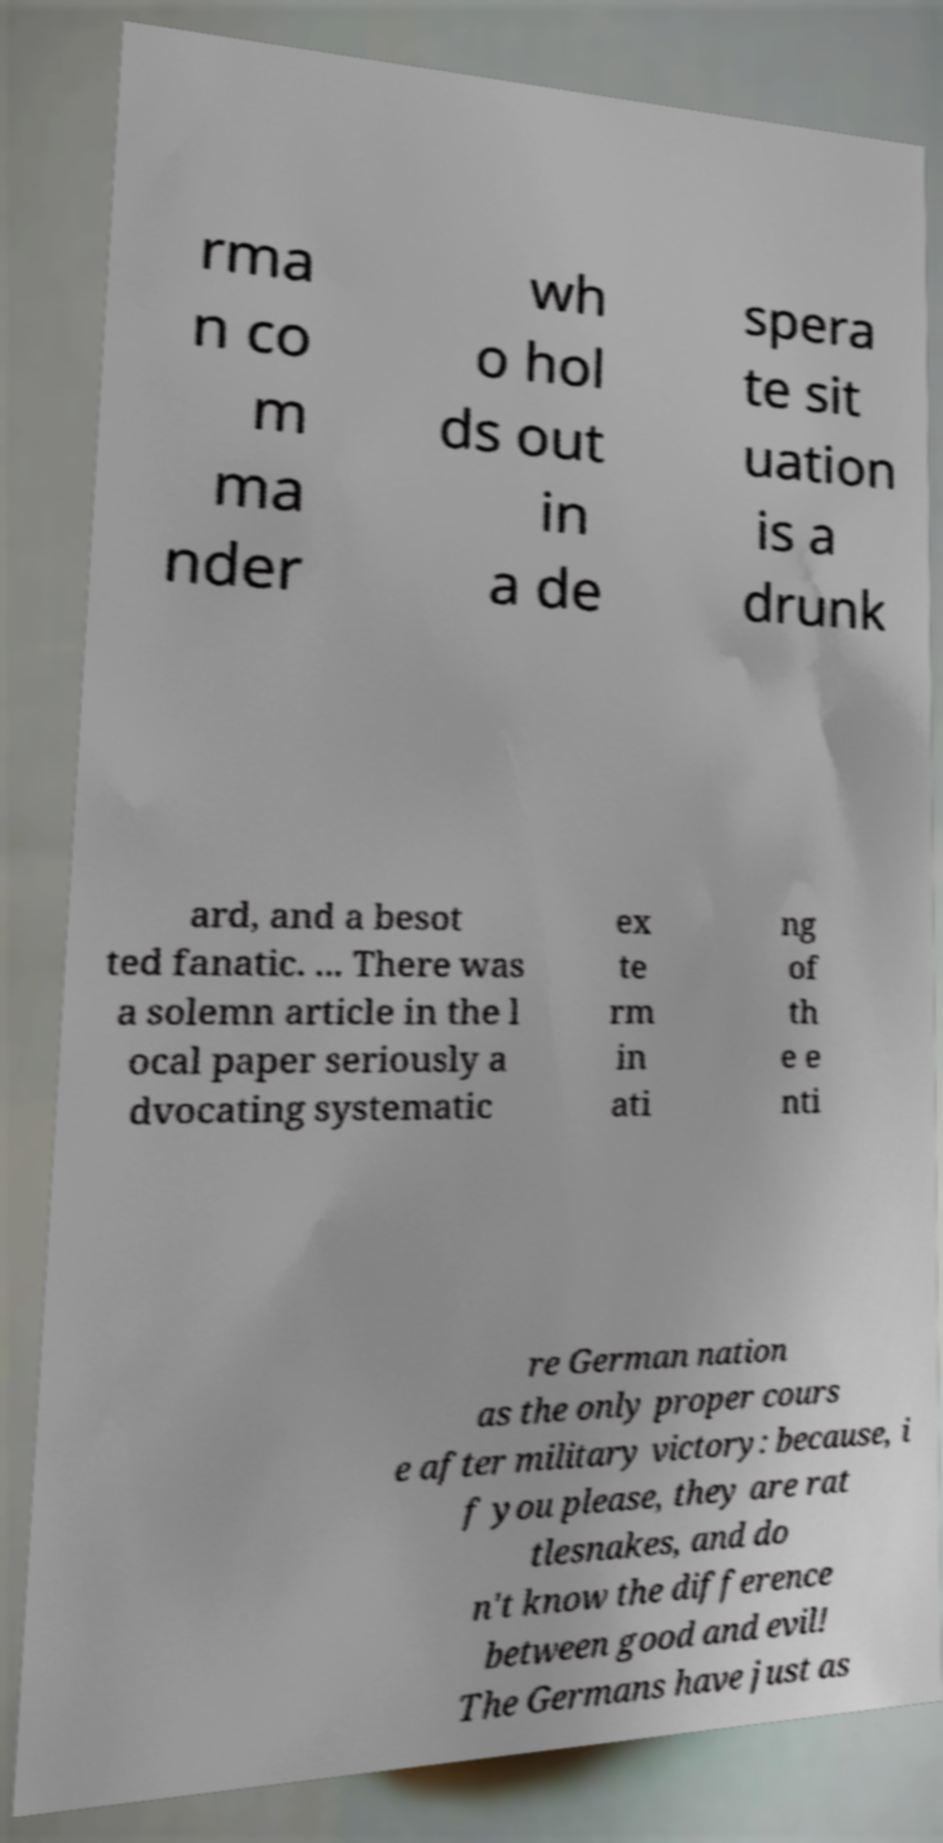I need the written content from this picture converted into text. Can you do that? rma n co m ma nder wh o hol ds out in a de spera te sit uation is a drunk ard, and a besot ted fanatic. ... There was a solemn article in the l ocal paper seriously a dvocating systematic ex te rm in ati ng of th e e nti re German nation as the only proper cours e after military victory: because, i f you please, they are rat tlesnakes, and do n't know the difference between good and evil! The Germans have just as 